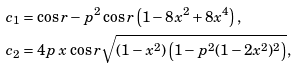Convert formula to latex. <formula><loc_0><loc_0><loc_500><loc_500>c _ { 1 } & = \cos { r } - p ^ { 2 } \cos { r } \left ( 1 - 8 x ^ { 2 } + 8 x ^ { 4 } \right ) , \\ c _ { 2 } & = 4 p \, x \, \cos { r } \sqrt { ( { 1 - x ^ { 2 } } ) \left ( 1 - p ^ { 2 } ( { 1 - 2 x ^ { 2 } } ) ^ { 2 } \right ) } ,</formula> 